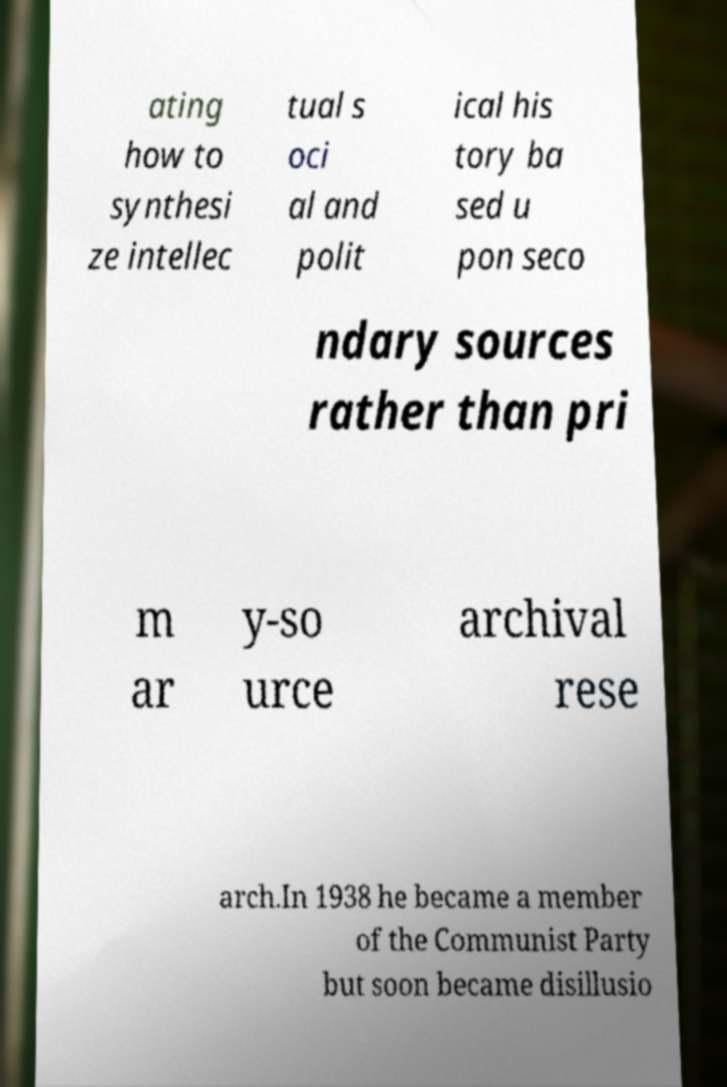Please identify and transcribe the text found in this image. ating how to synthesi ze intellec tual s oci al and polit ical his tory ba sed u pon seco ndary sources rather than pri m ar y-so urce archival rese arch.In 1938 he became a member of the Communist Party but soon became disillusio 